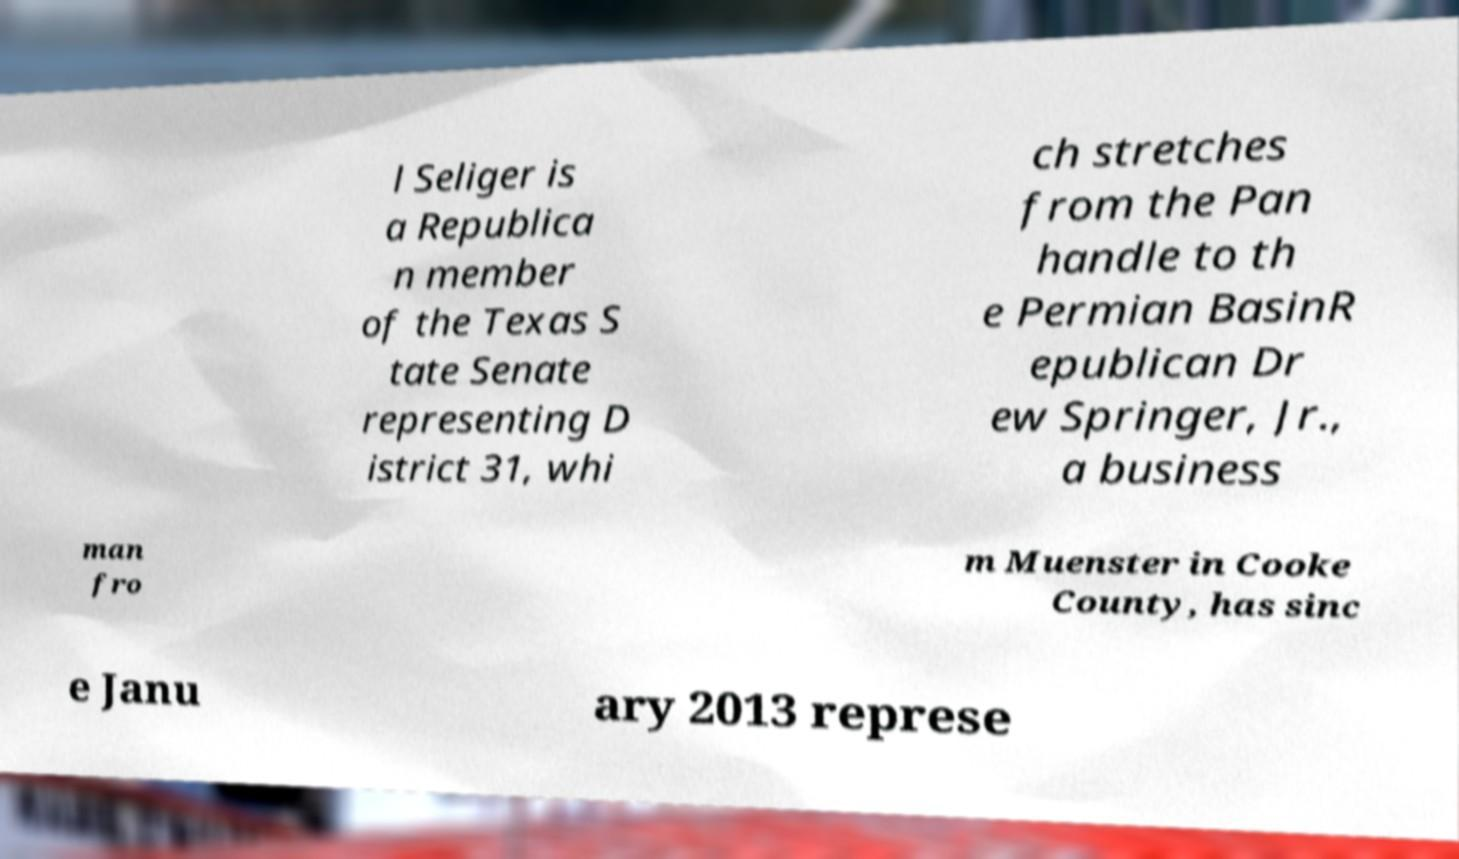Can you accurately transcribe the text from the provided image for me? l Seliger is a Republica n member of the Texas S tate Senate representing D istrict 31, whi ch stretches from the Pan handle to th e Permian BasinR epublican Dr ew Springer, Jr., a business man fro m Muenster in Cooke County, has sinc e Janu ary 2013 represe 